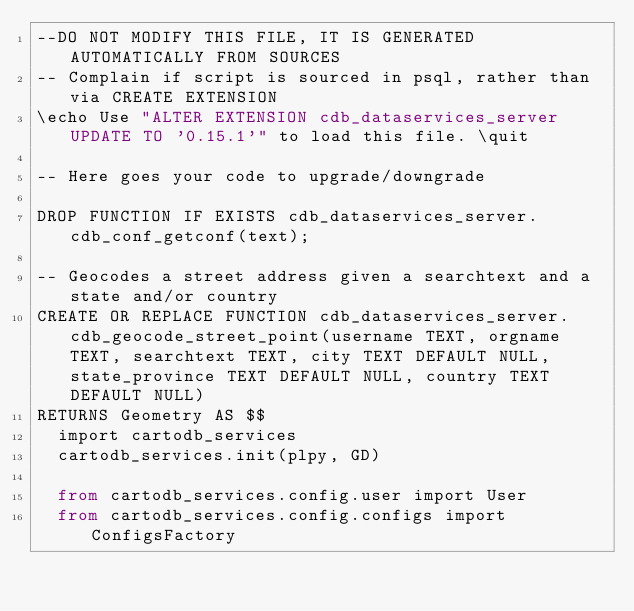Convert code to text. <code><loc_0><loc_0><loc_500><loc_500><_SQL_>--DO NOT MODIFY THIS FILE, IT IS GENERATED AUTOMATICALLY FROM SOURCES
-- Complain if script is sourced in psql, rather than via CREATE EXTENSION
\echo Use "ALTER EXTENSION cdb_dataservices_server UPDATE TO '0.15.1'" to load this file. \quit

-- Here goes your code to upgrade/downgrade

DROP FUNCTION IF EXISTS cdb_dataservices_server.cdb_conf_getconf(text);

-- Geocodes a street address given a searchtext and a state and/or country
CREATE OR REPLACE FUNCTION cdb_dataservices_server.cdb_geocode_street_point(username TEXT, orgname TEXT, searchtext TEXT, city TEXT DEFAULT NULL, state_province TEXT DEFAULT NULL, country TEXT DEFAULT NULL)
RETURNS Geometry AS $$
  import cartodb_services
  cartodb_services.init(plpy, GD)

  from cartodb_services.config.user import User
  from cartodb_services.config.configs import ConfigsFactory</code> 